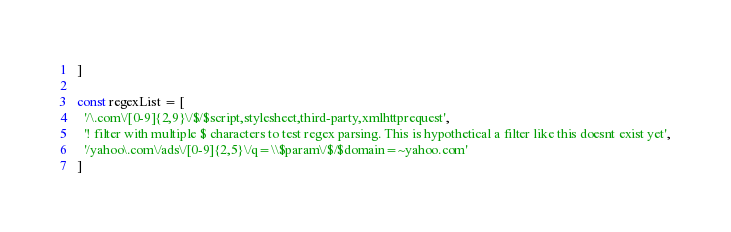<code> <loc_0><loc_0><loc_500><loc_500><_JavaScript_>]

const regexList = [
  '/\.com\/[0-9]{2,9}\/$/$script,stylesheet,third-party,xmlhttprequest',
  '! filter with multiple $ characters to test regex parsing. This is hypothetical a filter like this doesnt exist yet',
  '/yahoo\.com\/ads\/[0-9]{2,5}\/q=\\$param\/$/$domain=~yahoo.com'
]
</code> 